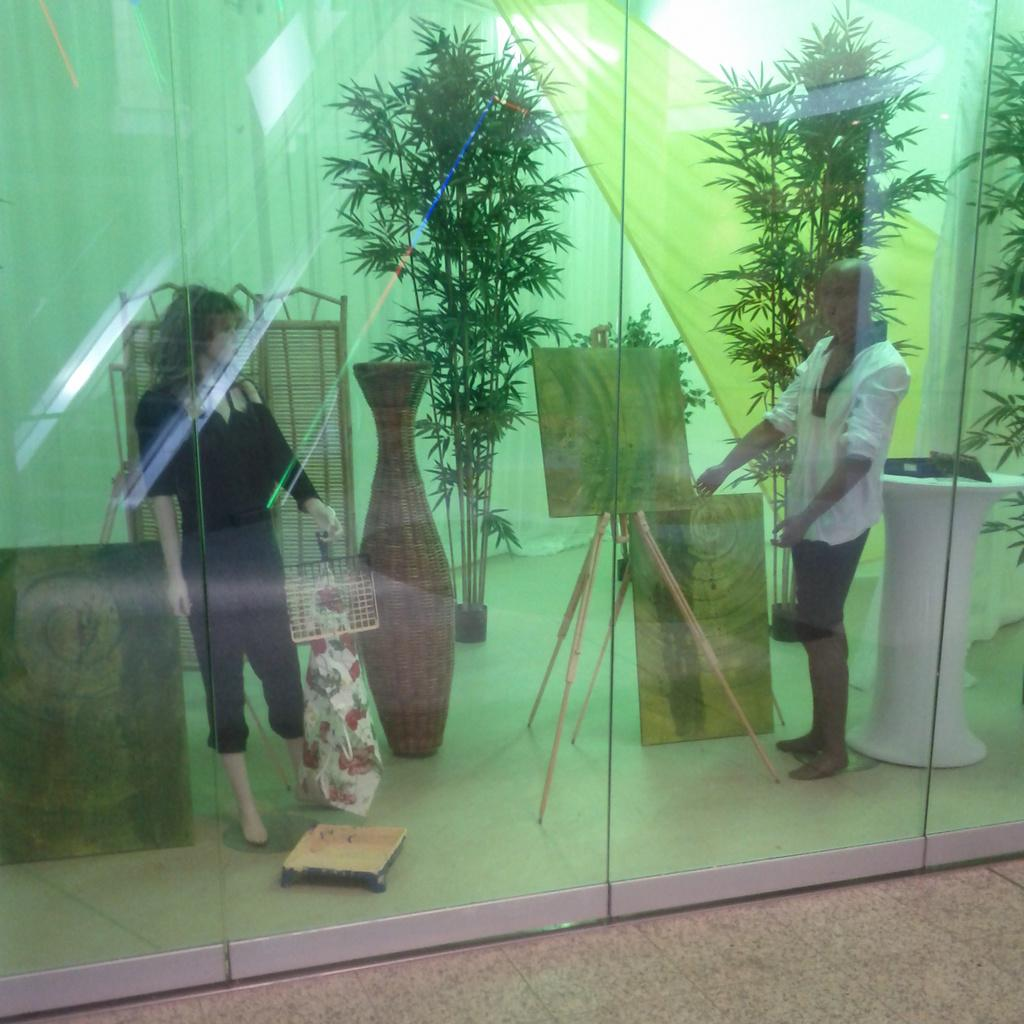What is the main feature in the center of the image? There is a glass door in the center of the image. What can be seen in the background of the image? There are manikins, boards, plants, flower pots, and some objects in the background of the image. What type of floor is visible at the bottom of the image? The floor visible at the bottom of the image is not specified in the facts. Where is the mailbox located in the image? There is no mailbox present in the image. What type of stick is being used by the manikins in the image? There are no sticks or manikins using sticks in the image. 